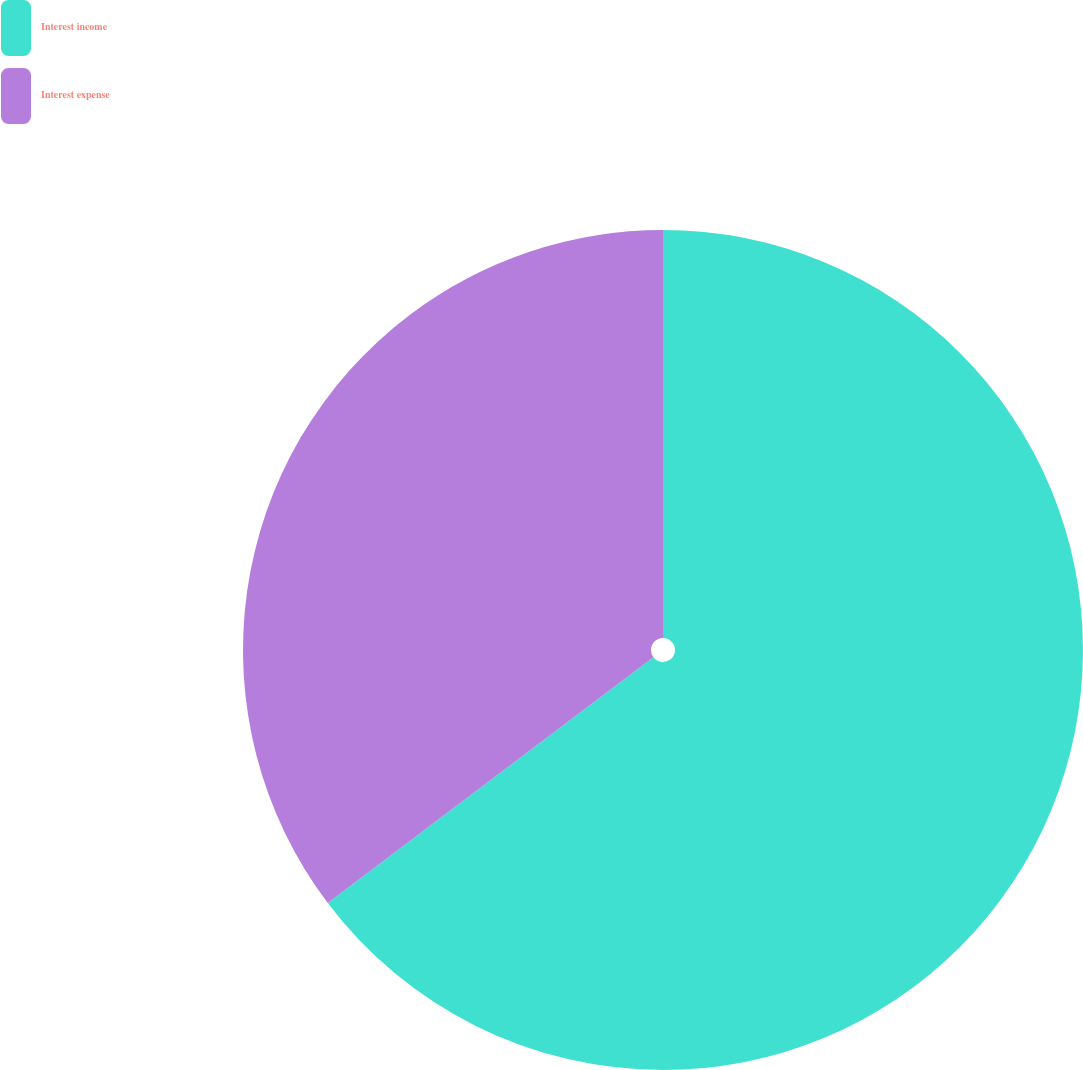Convert chart to OTSL. <chart><loc_0><loc_0><loc_500><loc_500><pie_chart><fcel>Interest income<fcel>Interest expense<nl><fcel>64.71%<fcel>35.29%<nl></chart> 